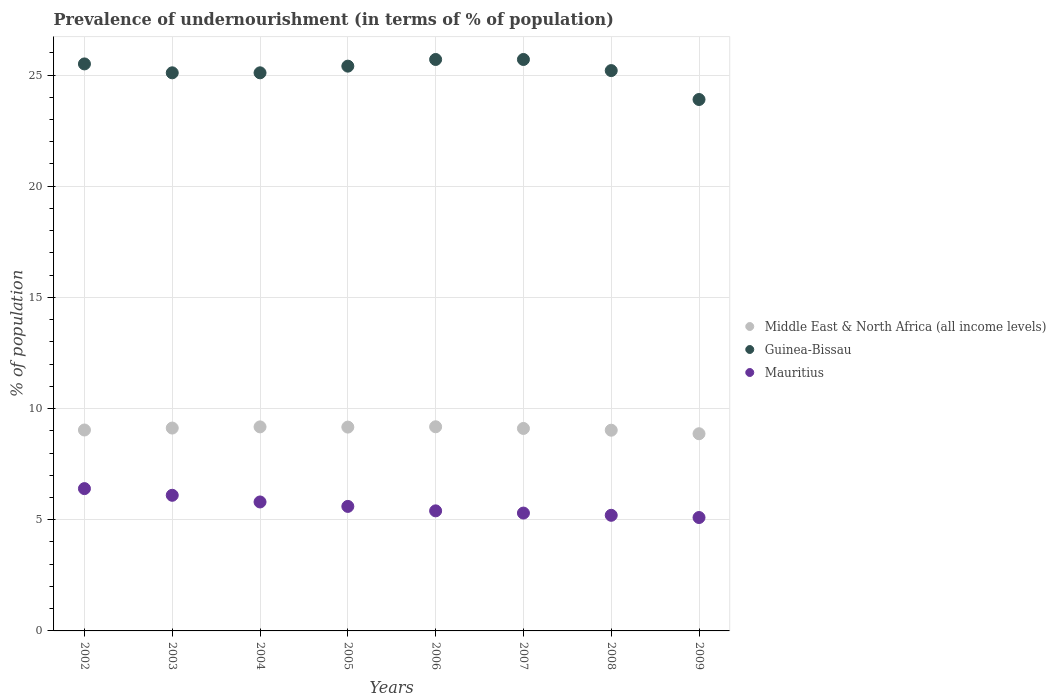How many different coloured dotlines are there?
Keep it short and to the point. 3. Is the number of dotlines equal to the number of legend labels?
Offer a very short reply. Yes. What is the percentage of undernourished population in Guinea-Bissau in 2008?
Offer a very short reply. 25.2. Across all years, what is the maximum percentage of undernourished population in Guinea-Bissau?
Your answer should be compact. 25.7. What is the total percentage of undernourished population in Middle East & North Africa (all income levels) in the graph?
Your answer should be very brief. 72.68. What is the difference between the percentage of undernourished population in Middle East & North Africa (all income levels) in 2004 and that in 2005?
Offer a very short reply. 0.01. What is the difference between the percentage of undernourished population in Guinea-Bissau in 2004 and the percentage of undernourished population in Mauritius in 2008?
Your answer should be very brief. 19.9. What is the average percentage of undernourished population in Middle East & North Africa (all income levels) per year?
Keep it short and to the point. 9.09. In the year 2007, what is the difference between the percentage of undernourished population in Guinea-Bissau and percentage of undernourished population in Mauritius?
Your answer should be very brief. 20.4. In how many years, is the percentage of undernourished population in Mauritius greater than 1 %?
Provide a short and direct response. 8. What is the ratio of the percentage of undernourished population in Middle East & North Africa (all income levels) in 2005 to that in 2006?
Provide a succinct answer. 1. Is the difference between the percentage of undernourished population in Guinea-Bissau in 2004 and 2008 greater than the difference between the percentage of undernourished population in Mauritius in 2004 and 2008?
Offer a terse response. No. What is the difference between the highest and the second highest percentage of undernourished population in Guinea-Bissau?
Provide a succinct answer. 0. What is the difference between the highest and the lowest percentage of undernourished population in Mauritius?
Provide a short and direct response. 1.3. In how many years, is the percentage of undernourished population in Mauritius greater than the average percentage of undernourished population in Mauritius taken over all years?
Give a very brief answer. 3. Is the percentage of undernourished population in Guinea-Bissau strictly greater than the percentage of undernourished population in Middle East & North Africa (all income levels) over the years?
Your answer should be compact. Yes. Is the percentage of undernourished population in Middle East & North Africa (all income levels) strictly less than the percentage of undernourished population in Mauritius over the years?
Keep it short and to the point. No. How many dotlines are there?
Make the answer very short. 3. How many years are there in the graph?
Ensure brevity in your answer.  8. Are the values on the major ticks of Y-axis written in scientific E-notation?
Your answer should be very brief. No. Does the graph contain any zero values?
Give a very brief answer. No. What is the title of the graph?
Your answer should be compact. Prevalence of undernourishment (in terms of % of population). What is the label or title of the Y-axis?
Make the answer very short. % of population. What is the % of population in Middle East & North Africa (all income levels) in 2002?
Your answer should be very brief. 9.04. What is the % of population in Mauritius in 2002?
Your answer should be compact. 6.4. What is the % of population of Middle East & North Africa (all income levels) in 2003?
Make the answer very short. 9.12. What is the % of population of Guinea-Bissau in 2003?
Ensure brevity in your answer.  25.1. What is the % of population in Mauritius in 2003?
Offer a terse response. 6.1. What is the % of population in Middle East & North Africa (all income levels) in 2004?
Make the answer very short. 9.18. What is the % of population in Guinea-Bissau in 2004?
Your response must be concise. 25.1. What is the % of population of Middle East & North Africa (all income levels) in 2005?
Ensure brevity in your answer.  9.17. What is the % of population of Guinea-Bissau in 2005?
Ensure brevity in your answer.  25.4. What is the % of population of Middle East & North Africa (all income levels) in 2006?
Provide a succinct answer. 9.18. What is the % of population in Guinea-Bissau in 2006?
Your answer should be compact. 25.7. What is the % of population of Middle East & North Africa (all income levels) in 2007?
Provide a succinct answer. 9.11. What is the % of population in Guinea-Bissau in 2007?
Your response must be concise. 25.7. What is the % of population in Middle East & North Africa (all income levels) in 2008?
Your response must be concise. 9.03. What is the % of population in Guinea-Bissau in 2008?
Keep it short and to the point. 25.2. What is the % of population of Middle East & North Africa (all income levels) in 2009?
Your response must be concise. 8.87. What is the % of population in Guinea-Bissau in 2009?
Give a very brief answer. 23.9. Across all years, what is the maximum % of population of Middle East & North Africa (all income levels)?
Offer a terse response. 9.18. Across all years, what is the maximum % of population in Guinea-Bissau?
Offer a very short reply. 25.7. Across all years, what is the minimum % of population in Middle East & North Africa (all income levels)?
Your answer should be very brief. 8.87. Across all years, what is the minimum % of population in Guinea-Bissau?
Ensure brevity in your answer.  23.9. Across all years, what is the minimum % of population in Mauritius?
Your response must be concise. 5.1. What is the total % of population of Middle East & North Africa (all income levels) in the graph?
Provide a short and direct response. 72.68. What is the total % of population of Guinea-Bissau in the graph?
Give a very brief answer. 201.6. What is the total % of population of Mauritius in the graph?
Give a very brief answer. 44.9. What is the difference between the % of population in Middle East & North Africa (all income levels) in 2002 and that in 2003?
Offer a very short reply. -0.09. What is the difference between the % of population of Guinea-Bissau in 2002 and that in 2003?
Ensure brevity in your answer.  0.4. What is the difference between the % of population in Middle East & North Africa (all income levels) in 2002 and that in 2004?
Provide a short and direct response. -0.14. What is the difference between the % of population of Middle East & North Africa (all income levels) in 2002 and that in 2005?
Keep it short and to the point. -0.13. What is the difference between the % of population in Guinea-Bissau in 2002 and that in 2005?
Ensure brevity in your answer.  0.1. What is the difference between the % of population of Mauritius in 2002 and that in 2005?
Your response must be concise. 0.8. What is the difference between the % of population in Middle East & North Africa (all income levels) in 2002 and that in 2006?
Keep it short and to the point. -0.14. What is the difference between the % of population in Guinea-Bissau in 2002 and that in 2006?
Ensure brevity in your answer.  -0.2. What is the difference between the % of population of Middle East & North Africa (all income levels) in 2002 and that in 2007?
Ensure brevity in your answer.  -0.07. What is the difference between the % of population of Guinea-Bissau in 2002 and that in 2007?
Keep it short and to the point. -0.2. What is the difference between the % of population in Mauritius in 2002 and that in 2007?
Your response must be concise. 1.1. What is the difference between the % of population in Middle East & North Africa (all income levels) in 2002 and that in 2008?
Offer a very short reply. 0.01. What is the difference between the % of population of Guinea-Bissau in 2002 and that in 2008?
Make the answer very short. 0.3. What is the difference between the % of population in Middle East & North Africa (all income levels) in 2002 and that in 2009?
Provide a succinct answer. 0.17. What is the difference between the % of population of Guinea-Bissau in 2002 and that in 2009?
Your answer should be very brief. 1.6. What is the difference between the % of population in Middle East & North Africa (all income levels) in 2003 and that in 2004?
Offer a very short reply. -0.05. What is the difference between the % of population in Middle East & North Africa (all income levels) in 2003 and that in 2005?
Ensure brevity in your answer.  -0.04. What is the difference between the % of population of Guinea-Bissau in 2003 and that in 2005?
Offer a terse response. -0.3. What is the difference between the % of population in Middle East & North Africa (all income levels) in 2003 and that in 2006?
Make the answer very short. -0.06. What is the difference between the % of population in Mauritius in 2003 and that in 2006?
Offer a terse response. 0.7. What is the difference between the % of population in Middle East & North Africa (all income levels) in 2003 and that in 2007?
Provide a short and direct response. 0.02. What is the difference between the % of population of Guinea-Bissau in 2003 and that in 2007?
Give a very brief answer. -0.6. What is the difference between the % of population in Middle East & North Africa (all income levels) in 2003 and that in 2008?
Offer a very short reply. 0.1. What is the difference between the % of population in Middle East & North Africa (all income levels) in 2003 and that in 2009?
Your answer should be compact. 0.26. What is the difference between the % of population of Middle East & North Africa (all income levels) in 2004 and that in 2005?
Ensure brevity in your answer.  0.01. What is the difference between the % of population of Middle East & North Africa (all income levels) in 2004 and that in 2006?
Provide a short and direct response. -0. What is the difference between the % of population of Guinea-Bissau in 2004 and that in 2006?
Provide a short and direct response. -0.6. What is the difference between the % of population in Middle East & North Africa (all income levels) in 2004 and that in 2007?
Your answer should be compact. 0.07. What is the difference between the % of population in Middle East & North Africa (all income levels) in 2004 and that in 2008?
Offer a terse response. 0.15. What is the difference between the % of population in Guinea-Bissau in 2004 and that in 2008?
Your answer should be compact. -0.1. What is the difference between the % of population of Mauritius in 2004 and that in 2008?
Your answer should be compact. 0.6. What is the difference between the % of population of Middle East & North Africa (all income levels) in 2004 and that in 2009?
Provide a succinct answer. 0.31. What is the difference between the % of population of Guinea-Bissau in 2004 and that in 2009?
Your response must be concise. 1.2. What is the difference between the % of population in Middle East & North Africa (all income levels) in 2005 and that in 2006?
Your response must be concise. -0.01. What is the difference between the % of population of Guinea-Bissau in 2005 and that in 2006?
Give a very brief answer. -0.3. What is the difference between the % of population in Middle East & North Africa (all income levels) in 2005 and that in 2007?
Provide a succinct answer. 0.06. What is the difference between the % of population in Mauritius in 2005 and that in 2007?
Give a very brief answer. 0.3. What is the difference between the % of population of Middle East & North Africa (all income levels) in 2005 and that in 2008?
Your answer should be compact. 0.14. What is the difference between the % of population in Mauritius in 2005 and that in 2008?
Offer a very short reply. 0.4. What is the difference between the % of population of Middle East & North Africa (all income levels) in 2005 and that in 2009?
Offer a terse response. 0.3. What is the difference between the % of population of Middle East & North Africa (all income levels) in 2006 and that in 2007?
Make the answer very short. 0.08. What is the difference between the % of population in Middle East & North Africa (all income levels) in 2006 and that in 2008?
Your response must be concise. 0.15. What is the difference between the % of population in Mauritius in 2006 and that in 2008?
Provide a short and direct response. 0.2. What is the difference between the % of population in Middle East & North Africa (all income levels) in 2006 and that in 2009?
Keep it short and to the point. 0.31. What is the difference between the % of population in Guinea-Bissau in 2006 and that in 2009?
Provide a succinct answer. 1.8. What is the difference between the % of population in Middle East & North Africa (all income levels) in 2007 and that in 2008?
Your response must be concise. 0.08. What is the difference between the % of population of Guinea-Bissau in 2007 and that in 2008?
Keep it short and to the point. 0.5. What is the difference between the % of population of Middle East & North Africa (all income levels) in 2007 and that in 2009?
Ensure brevity in your answer.  0.24. What is the difference between the % of population of Guinea-Bissau in 2007 and that in 2009?
Your answer should be very brief. 1.8. What is the difference between the % of population of Mauritius in 2007 and that in 2009?
Your response must be concise. 0.2. What is the difference between the % of population of Middle East & North Africa (all income levels) in 2008 and that in 2009?
Your response must be concise. 0.16. What is the difference between the % of population in Middle East & North Africa (all income levels) in 2002 and the % of population in Guinea-Bissau in 2003?
Give a very brief answer. -16.06. What is the difference between the % of population of Middle East & North Africa (all income levels) in 2002 and the % of population of Mauritius in 2003?
Keep it short and to the point. 2.94. What is the difference between the % of population in Middle East & North Africa (all income levels) in 2002 and the % of population in Guinea-Bissau in 2004?
Your answer should be very brief. -16.06. What is the difference between the % of population in Middle East & North Africa (all income levels) in 2002 and the % of population in Mauritius in 2004?
Keep it short and to the point. 3.24. What is the difference between the % of population in Middle East & North Africa (all income levels) in 2002 and the % of population in Guinea-Bissau in 2005?
Your answer should be compact. -16.36. What is the difference between the % of population of Middle East & North Africa (all income levels) in 2002 and the % of population of Mauritius in 2005?
Ensure brevity in your answer.  3.44. What is the difference between the % of population in Guinea-Bissau in 2002 and the % of population in Mauritius in 2005?
Ensure brevity in your answer.  19.9. What is the difference between the % of population in Middle East & North Africa (all income levels) in 2002 and the % of population in Guinea-Bissau in 2006?
Ensure brevity in your answer.  -16.66. What is the difference between the % of population of Middle East & North Africa (all income levels) in 2002 and the % of population of Mauritius in 2006?
Give a very brief answer. 3.64. What is the difference between the % of population of Guinea-Bissau in 2002 and the % of population of Mauritius in 2006?
Keep it short and to the point. 20.1. What is the difference between the % of population in Middle East & North Africa (all income levels) in 2002 and the % of population in Guinea-Bissau in 2007?
Provide a short and direct response. -16.66. What is the difference between the % of population in Middle East & North Africa (all income levels) in 2002 and the % of population in Mauritius in 2007?
Keep it short and to the point. 3.74. What is the difference between the % of population of Guinea-Bissau in 2002 and the % of population of Mauritius in 2007?
Provide a succinct answer. 20.2. What is the difference between the % of population in Middle East & North Africa (all income levels) in 2002 and the % of population in Guinea-Bissau in 2008?
Keep it short and to the point. -16.16. What is the difference between the % of population in Middle East & North Africa (all income levels) in 2002 and the % of population in Mauritius in 2008?
Make the answer very short. 3.84. What is the difference between the % of population of Guinea-Bissau in 2002 and the % of population of Mauritius in 2008?
Provide a short and direct response. 20.3. What is the difference between the % of population in Middle East & North Africa (all income levels) in 2002 and the % of population in Guinea-Bissau in 2009?
Your answer should be compact. -14.86. What is the difference between the % of population of Middle East & North Africa (all income levels) in 2002 and the % of population of Mauritius in 2009?
Make the answer very short. 3.94. What is the difference between the % of population in Guinea-Bissau in 2002 and the % of population in Mauritius in 2009?
Make the answer very short. 20.4. What is the difference between the % of population in Middle East & North Africa (all income levels) in 2003 and the % of population in Guinea-Bissau in 2004?
Provide a succinct answer. -15.98. What is the difference between the % of population in Middle East & North Africa (all income levels) in 2003 and the % of population in Mauritius in 2004?
Give a very brief answer. 3.32. What is the difference between the % of population in Guinea-Bissau in 2003 and the % of population in Mauritius in 2004?
Ensure brevity in your answer.  19.3. What is the difference between the % of population of Middle East & North Africa (all income levels) in 2003 and the % of population of Guinea-Bissau in 2005?
Your response must be concise. -16.28. What is the difference between the % of population in Middle East & North Africa (all income levels) in 2003 and the % of population in Mauritius in 2005?
Your answer should be compact. 3.52. What is the difference between the % of population in Guinea-Bissau in 2003 and the % of population in Mauritius in 2005?
Ensure brevity in your answer.  19.5. What is the difference between the % of population in Middle East & North Africa (all income levels) in 2003 and the % of population in Guinea-Bissau in 2006?
Offer a terse response. -16.58. What is the difference between the % of population in Middle East & North Africa (all income levels) in 2003 and the % of population in Mauritius in 2006?
Your answer should be very brief. 3.72. What is the difference between the % of population of Middle East & North Africa (all income levels) in 2003 and the % of population of Guinea-Bissau in 2007?
Offer a terse response. -16.58. What is the difference between the % of population of Middle East & North Africa (all income levels) in 2003 and the % of population of Mauritius in 2007?
Provide a succinct answer. 3.82. What is the difference between the % of population of Guinea-Bissau in 2003 and the % of population of Mauritius in 2007?
Offer a terse response. 19.8. What is the difference between the % of population of Middle East & North Africa (all income levels) in 2003 and the % of population of Guinea-Bissau in 2008?
Your answer should be very brief. -16.08. What is the difference between the % of population of Middle East & North Africa (all income levels) in 2003 and the % of population of Mauritius in 2008?
Provide a succinct answer. 3.92. What is the difference between the % of population of Middle East & North Africa (all income levels) in 2003 and the % of population of Guinea-Bissau in 2009?
Provide a short and direct response. -14.78. What is the difference between the % of population in Middle East & North Africa (all income levels) in 2003 and the % of population in Mauritius in 2009?
Give a very brief answer. 4.02. What is the difference between the % of population in Middle East & North Africa (all income levels) in 2004 and the % of population in Guinea-Bissau in 2005?
Keep it short and to the point. -16.22. What is the difference between the % of population of Middle East & North Africa (all income levels) in 2004 and the % of population of Mauritius in 2005?
Your answer should be compact. 3.58. What is the difference between the % of population in Middle East & North Africa (all income levels) in 2004 and the % of population in Guinea-Bissau in 2006?
Keep it short and to the point. -16.52. What is the difference between the % of population of Middle East & North Africa (all income levels) in 2004 and the % of population of Mauritius in 2006?
Give a very brief answer. 3.78. What is the difference between the % of population in Middle East & North Africa (all income levels) in 2004 and the % of population in Guinea-Bissau in 2007?
Make the answer very short. -16.52. What is the difference between the % of population in Middle East & North Africa (all income levels) in 2004 and the % of population in Mauritius in 2007?
Make the answer very short. 3.88. What is the difference between the % of population in Guinea-Bissau in 2004 and the % of population in Mauritius in 2007?
Provide a short and direct response. 19.8. What is the difference between the % of population of Middle East & North Africa (all income levels) in 2004 and the % of population of Guinea-Bissau in 2008?
Your response must be concise. -16.02. What is the difference between the % of population of Middle East & North Africa (all income levels) in 2004 and the % of population of Mauritius in 2008?
Your answer should be very brief. 3.98. What is the difference between the % of population in Guinea-Bissau in 2004 and the % of population in Mauritius in 2008?
Offer a very short reply. 19.9. What is the difference between the % of population of Middle East & North Africa (all income levels) in 2004 and the % of population of Guinea-Bissau in 2009?
Make the answer very short. -14.72. What is the difference between the % of population in Middle East & North Africa (all income levels) in 2004 and the % of population in Mauritius in 2009?
Offer a terse response. 4.08. What is the difference between the % of population in Guinea-Bissau in 2004 and the % of population in Mauritius in 2009?
Offer a very short reply. 20. What is the difference between the % of population of Middle East & North Africa (all income levels) in 2005 and the % of population of Guinea-Bissau in 2006?
Offer a terse response. -16.53. What is the difference between the % of population of Middle East & North Africa (all income levels) in 2005 and the % of population of Mauritius in 2006?
Keep it short and to the point. 3.77. What is the difference between the % of population in Middle East & North Africa (all income levels) in 2005 and the % of population in Guinea-Bissau in 2007?
Provide a succinct answer. -16.53. What is the difference between the % of population of Middle East & North Africa (all income levels) in 2005 and the % of population of Mauritius in 2007?
Make the answer very short. 3.87. What is the difference between the % of population in Guinea-Bissau in 2005 and the % of population in Mauritius in 2007?
Make the answer very short. 20.1. What is the difference between the % of population of Middle East & North Africa (all income levels) in 2005 and the % of population of Guinea-Bissau in 2008?
Your answer should be compact. -16.03. What is the difference between the % of population in Middle East & North Africa (all income levels) in 2005 and the % of population in Mauritius in 2008?
Make the answer very short. 3.97. What is the difference between the % of population of Guinea-Bissau in 2005 and the % of population of Mauritius in 2008?
Ensure brevity in your answer.  20.2. What is the difference between the % of population of Middle East & North Africa (all income levels) in 2005 and the % of population of Guinea-Bissau in 2009?
Make the answer very short. -14.73. What is the difference between the % of population of Middle East & North Africa (all income levels) in 2005 and the % of population of Mauritius in 2009?
Keep it short and to the point. 4.07. What is the difference between the % of population of Guinea-Bissau in 2005 and the % of population of Mauritius in 2009?
Ensure brevity in your answer.  20.3. What is the difference between the % of population of Middle East & North Africa (all income levels) in 2006 and the % of population of Guinea-Bissau in 2007?
Provide a short and direct response. -16.52. What is the difference between the % of population in Middle East & North Africa (all income levels) in 2006 and the % of population in Mauritius in 2007?
Give a very brief answer. 3.88. What is the difference between the % of population in Guinea-Bissau in 2006 and the % of population in Mauritius in 2007?
Offer a terse response. 20.4. What is the difference between the % of population of Middle East & North Africa (all income levels) in 2006 and the % of population of Guinea-Bissau in 2008?
Keep it short and to the point. -16.02. What is the difference between the % of population in Middle East & North Africa (all income levels) in 2006 and the % of population in Mauritius in 2008?
Make the answer very short. 3.98. What is the difference between the % of population in Middle East & North Africa (all income levels) in 2006 and the % of population in Guinea-Bissau in 2009?
Offer a very short reply. -14.72. What is the difference between the % of population of Middle East & North Africa (all income levels) in 2006 and the % of population of Mauritius in 2009?
Your response must be concise. 4.08. What is the difference between the % of population of Guinea-Bissau in 2006 and the % of population of Mauritius in 2009?
Provide a short and direct response. 20.6. What is the difference between the % of population in Middle East & North Africa (all income levels) in 2007 and the % of population in Guinea-Bissau in 2008?
Provide a short and direct response. -16.09. What is the difference between the % of population in Middle East & North Africa (all income levels) in 2007 and the % of population in Mauritius in 2008?
Provide a succinct answer. 3.91. What is the difference between the % of population in Guinea-Bissau in 2007 and the % of population in Mauritius in 2008?
Provide a succinct answer. 20.5. What is the difference between the % of population of Middle East & North Africa (all income levels) in 2007 and the % of population of Guinea-Bissau in 2009?
Make the answer very short. -14.79. What is the difference between the % of population in Middle East & North Africa (all income levels) in 2007 and the % of population in Mauritius in 2009?
Your response must be concise. 4.01. What is the difference between the % of population in Guinea-Bissau in 2007 and the % of population in Mauritius in 2009?
Make the answer very short. 20.6. What is the difference between the % of population in Middle East & North Africa (all income levels) in 2008 and the % of population in Guinea-Bissau in 2009?
Give a very brief answer. -14.87. What is the difference between the % of population in Middle East & North Africa (all income levels) in 2008 and the % of population in Mauritius in 2009?
Keep it short and to the point. 3.93. What is the difference between the % of population of Guinea-Bissau in 2008 and the % of population of Mauritius in 2009?
Your answer should be very brief. 20.1. What is the average % of population in Middle East & North Africa (all income levels) per year?
Offer a terse response. 9.09. What is the average % of population of Guinea-Bissau per year?
Offer a very short reply. 25.2. What is the average % of population of Mauritius per year?
Your answer should be very brief. 5.61. In the year 2002, what is the difference between the % of population in Middle East & North Africa (all income levels) and % of population in Guinea-Bissau?
Provide a short and direct response. -16.46. In the year 2002, what is the difference between the % of population in Middle East & North Africa (all income levels) and % of population in Mauritius?
Ensure brevity in your answer.  2.64. In the year 2002, what is the difference between the % of population of Guinea-Bissau and % of population of Mauritius?
Make the answer very short. 19.1. In the year 2003, what is the difference between the % of population in Middle East & North Africa (all income levels) and % of population in Guinea-Bissau?
Offer a very short reply. -15.98. In the year 2003, what is the difference between the % of population of Middle East & North Africa (all income levels) and % of population of Mauritius?
Your answer should be compact. 3.02. In the year 2004, what is the difference between the % of population in Middle East & North Africa (all income levels) and % of population in Guinea-Bissau?
Your response must be concise. -15.92. In the year 2004, what is the difference between the % of population in Middle East & North Africa (all income levels) and % of population in Mauritius?
Give a very brief answer. 3.38. In the year 2004, what is the difference between the % of population in Guinea-Bissau and % of population in Mauritius?
Ensure brevity in your answer.  19.3. In the year 2005, what is the difference between the % of population of Middle East & North Africa (all income levels) and % of population of Guinea-Bissau?
Ensure brevity in your answer.  -16.23. In the year 2005, what is the difference between the % of population in Middle East & North Africa (all income levels) and % of population in Mauritius?
Ensure brevity in your answer.  3.57. In the year 2005, what is the difference between the % of population in Guinea-Bissau and % of population in Mauritius?
Give a very brief answer. 19.8. In the year 2006, what is the difference between the % of population in Middle East & North Africa (all income levels) and % of population in Guinea-Bissau?
Ensure brevity in your answer.  -16.52. In the year 2006, what is the difference between the % of population in Middle East & North Africa (all income levels) and % of population in Mauritius?
Offer a very short reply. 3.78. In the year 2006, what is the difference between the % of population in Guinea-Bissau and % of population in Mauritius?
Provide a short and direct response. 20.3. In the year 2007, what is the difference between the % of population of Middle East & North Africa (all income levels) and % of population of Guinea-Bissau?
Your response must be concise. -16.59. In the year 2007, what is the difference between the % of population in Middle East & North Africa (all income levels) and % of population in Mauritius?
Your answer should be compact. 3.81. In the year 2007, what is the difference between the % of population of Guinea-Bissau and % of population of Mauritius?
Your answer should be very brief. 20.4. In the year 2008, what is the difference between the % of population of Middle East & North Africa (all income levels) and % of population of Guinea-Bissau?
Offer a very short reply. -16.17. In the year 2008, what is the difference between the % of population in Middle East & North Africa (all income levels) and % of population in Mauritius?
Your answer should be very brief. 3.83. In the year 2008, what is the difference between the % of population of Guinea-Bissau and % of population of Mauritius?
Ensure brevity in your answer.  20. In the year 2009, what is the difference between the % of population in Middle East & North Africa (all income levels) and % of population in Guinea-Bissau?
Provide a succinct answer. -15.03. In the year 2009, what is the difference between the % of population in Middle East & North Africa (all income levels) and % of population in Mauritius?
Ensure brevity in your answer.  3.77. What is the ratio of the % of population in Guinea-Bissau in 2002 to that in 2003?
Offer a terse response. 1.02. What is the ratio of the % of population of Mauritius in 2002 to that in 2003?
Your answer should be compact. 1.05. What is the ratio of the % of population in Middle East & North Africa (all income levels) in 2002 to that in 2004?
Provide a succinct answer. 0.98. What is the ratio of the % of population in Guinea-Bissau in 2002 to that in 2004?
Ensure brevity in your answer.  1.02. What is the ratio of the % of population of Mauritius in 2002 to that in 2004?
Ensure brevity in your answer.  1.1. What is the ratio of the % of population of Middle East & North Africa (all income levels) in 2002 to that in 2005?
Your response must be concise. 0.99. What is the ratio of the % of population of Middle East & North Africa (all income levels) in 2002 to that in 2006?
Your response must be concise. 0.98. What is the ratio of the % of population of Mauritius in 2002 to that in 2006?
Give a very brief answer. 1.19. What is the ratio of the % of population in Middle East & North Africa (all income levels) in 2002 to that in 2007?
Make the answer very short. 0.99. What is the ratio of the % of population in Guinea-Bissau in 2002 to that in 2007?
Provide a succinct answer. 0.99. What is the ratio of the % of population in Mauritius in 2002 to that in 2007?
Offer a terse response. 1.21. What is the ratio of the % of population of Guinea-Bissau in 2002 to that in 2008?
Make the answer very short. 1.01. What is the ratio of the % of population in Mauritius in 2002 to that in 2008?
Keep it short and to the point. 1.23. What is the ratio of the % of population of Middle East & North Africa (all income levels) in 2002 to that in 2009?
Offer a very short reply. 1.02. What is the ratio of the % of population of Guinea-Bissau in 2002 to that in 2009?
Offer a very short reply. 1.07. What is the ratio of the % of population in Mauritius in 2002 to that in 2009?
Your response must be concise. 1.25. What is the ratio of the % of population of Mauritius in 2003 to that in 2004?
Offer a very short reply. 1.05. What is the ratio of the % of population in Middle East & North Africa (all income levels) in 2003 to that in 2005?
Provide a short and direct response. 1. What is the ratio of the % of population in Mauritius in 2003 to that in 2005?
Provide a short and direct response. 1.09. What is the ratio of the % of population in Middle East & North Africa (all income levels) in 2003 to that in 2006?
Ensure brevity in your answer.  0.99. What is the ratio of the % of population of Guinea-Bissau in 2003 to that in 2006?
Offer a terse response. 0.98. What is the ratio of the % of population of Mauritius in 2003 to that in 2006?
Ensure brevity in your answer.  1.13. What is the ratio of the % of population in Middle East & North Africa (all income levels) in 2003 to that in 2007?
Ensure brevity in your answer.  1. What is the ratio of the % of population of Guinea-Bissau in 2003 to that in 2007?
Offer a terse response. 0.98. What is the ratio of the % of population of Mauritius in 2003 to that in 2007?
Your answer should be compact. 1.15. What is the ratio of the % of population of Middle East & North Africa (all income levels) in 2003 to that in 2008?
Give a very brief answer. 1.01. What is the ratio of the % of population in Guinea-Bissau in 2003 to that in 2008?
Your answer should be very brief. 1. What is the ratio of the % of population in Mauritius in 2003 to that in 2008?
Offer a terse response. 1.17. What is the ratio of the % of population in Middle East & North Africa (all income levels) in 2003 to that in 2009?
Your answer should be very brief. 1.03. What is the ratio of the % of population of Guinea-Bissau in 2003 to that in 2009?
Your response must be concise. 1.05. What is the ratio of the % of population of Mauritius in 2003 to that in 2009?
Make the answer very short. 1.2. What is the ratio of the % of population in Middle East & North Africa (all income levels) in 2004 to that in 2005?
Give a very brief answer. 1. What is the ratio of the % of population of Mauritius in 2004 to that in 2005?
Give a very brief answer. 1.04. What is the ratio of the % of population of Guinea-Bissau in 2004 to that in 2006?
Make the answer very short. 0.98. What is the ratio of the % of population of Mauritius in 2004 to that in 2006?
Make the answer very short. 1.07. What is the ratio of the % of population in Guinea-Bissau in 2004 to that in 2007?
Keep it short and to the point. 0.98. What is the ratio of the % of population in Mauritius in 2004 to that in 2007?
Ensure brevity in your answer.  1.09. What is the ratio of the % of population in Middle East & North Africa (all income levels) in 2004 to that in 2008?
Make the answer very short. 1.02. What is the ratio of the % of population in Guinea-Bissau in 2004 to that in 2008?
Offer a terse response. 1. What is the ratio of the % of population of Mauritius in 2004 to that in 2008?
Offer a terse response. 1.12. What is the ratio of the % of population in Middle East & North Africa (all income levels) in 2004 to that in 2009?
Offer a very short reply. 1.03. What is the ratio of the % of population in Guinea-Bissau in 2004 to that in 2009?
Provide a succinct answer. 1.05. What is the ratio of the % of population of Mauritius in 2004 to that in 2009?
Ensure brevity in your answer.  1.14. What is the ratio of the % of population of Guinea-Bissau in 2005 to that in 2006?
Provide a succinct answer. 0.99. What is the ratio of the % of population of Mauritius in 2005 to that in 2006?
Give a very brief answer. 1.04. What is the ratio of the % of population of Middle East & North Africa (all income levels) in 2005 to that in 2007?
Your response must be concise. 1.01. What is the ratio of the % of population in Guinea-Bissau in 2005 to that in 2007?
Offer a terse response. 0.99. What is the ratio of the % of population in Mauritius in 2005 to that in 2007?
Provide a short and direct response. 1.06. What is the ratio of the % of population of Middle East & North Africa (all income levels) in 2005 to that in 2008?
Give a very brief answer. 1.02. What is the ratio of the % of population in Guinea-Bissau in 2005 to that in 2008?
Your answer should be compact. 1.01. What is the ratio of the % of population of Middle East & North Africa (all income levels) in 2005 to that in 2009?
Your answer should be compact. 1.03. What is the ratio of the % of population in Guinea-Bissau in 2005 to that in 2009?
Offer a very short reply. 1.06. What is the ratio of the % of population in Mauritius in 2005 to that in 2009?
Offer a terse response. 1.1. What is the ratio of the % of population in Middle East & North Africa (all income levels) in 2006 to that in 2007?
Keep it short and to the point. 1.01. What is the ratio of the % of population of Guinea-Bissau in 2006 to that in 2007?
Offer a terse response. 1. What is the ratio of the % of population of Mauritius in 2006 to that in 2007?
Keep it short and to the point. 1.02. What is the ratio of the % of population in Middle East & North Africa (all income levels) in 2006 to that in 2008?
Offer a terse response. 1.02. What is the ratio of the % of population of Guinea-Bissau in 2006 to that in 2008?
Make the answer very short. 1.02. What is the ratio of the % of population in Mauritius in 2006 to that in 2008?
Your response must be concise. 1.04. What is the ratio of the % of population of Middle East & North Africa (all income levels) in 2006 to that in 2009?
Provide a succinct answer. 1.04. What is the ratio of the % of population of Guinea-Bissau in 2006 to that in 2009?
Your response must be concise. 1.08. What is the ratio of the % of population in Mauritius in 2006 to that in 2009?
Your answer should be compact. 1.06. What is the ratio of the % of population in Middle East & North Africa (all income levels) in 2007 to that in 2008?
Make the answer very short. 1.01. What is the ratio of the % of population in Guinea-Bissau in 2007 to that in 2008?
Make the answer very short. 1.02. What is the ratio of the % of population in Mauritius in 2007 to that in 2008?
Ensure brevity in your answer.  1.02. What is the ratio of the % of population of Middle East & North Africa (all income levels) in 2007 to that in 2009?
Provide a succinct answer. 1.03. What is the ratio of the % of population of Guinea-Bissau in 2007 to that in 2009?
Provide a short and direct response. 1.08. What is the ratio of the % of population in Mauritius in 2007 to that in 2009?
Your answer should be very brief. 1.04. What is the ratio of the % of population in Middle East & North Africa (all income levels) in 2008 to that in 2009?
Your response must be concise. 1.02. What is the ratio of the % of population in Guinea-Bissau in 2008 to that in 2009?
Offer a terse response. 1.05. What is the ratio of the % of population in Mauritius in 2008 to that in 2009?
Offer a terse response. 1.02. What is the difference between the highest and the second highest % of population in Middle East & North Africa (all income levels)?
Ensure brevity in your answer.  0. What is the difference between the highest and the second highest % of population in Mauritius?
Offer a very short reply. 0.3. What is the difference between the highest and the lowest % of population in Middle East & North Africa (all income levels)?
Your answer should be compact. 0.31. What is the difference between the highest and the lowest % of population of Mauritius?
Offer a terse response. 1.3. 